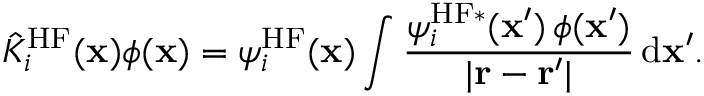Convert formula to latex. <formula><loc_0><loc_0><loc_500><loc_500>\hat { K } _ { i } ^ { H F } ( x ) \phi ( x ) = \psi _ { i } ^ { H F } ( x ) \int \frac { \psi _ { i } ^ { H F \ast } ( x ^ { \prime } ) \, \phi ( x ^ { \prime } ) } { | r - r ^ { \prime } | } \, d x ^ { \prime } .</formula> 